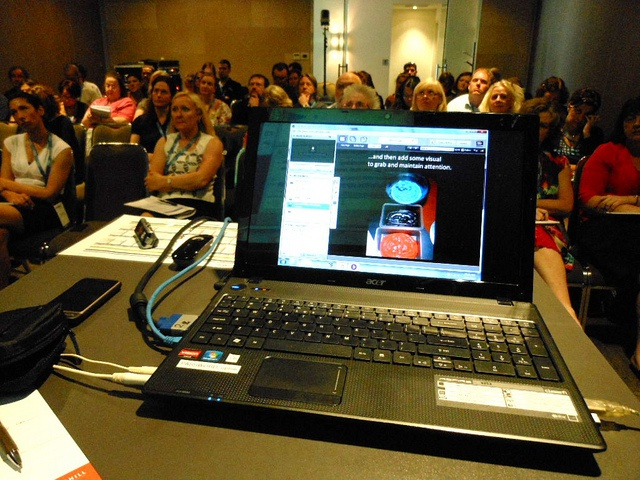Describe the objects in this image and their specific colors. I can see laptop in black, olive, ivory, and teal tones, people in black, maroon, and olive tones, people in black, maroon, brown, and tan tones, people in black, brown, maroon, and olive tones, and chair in black, maroon, olive, and tan tones in this image. 